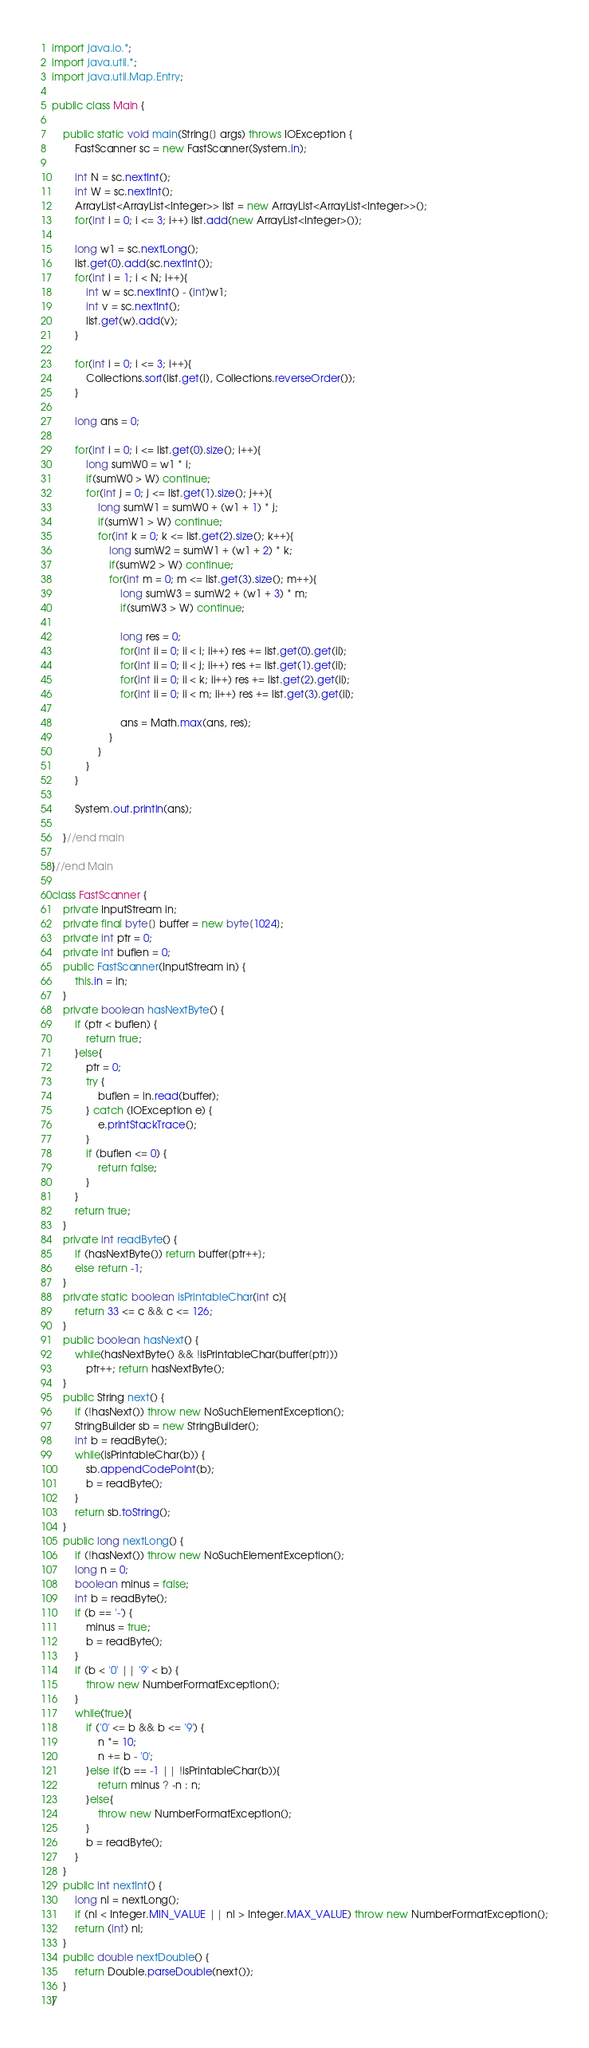<code> <loc_0><loc_0><loc_500><loc_500><_Java_>import java.io.*;
import java.util.*;
import java.util.Map.Entry;

public class Main {
		
	public static void main(String[] args) throws IOException {
		FastScanner sc = new FastScanner(System.in);
		
		int N = sc.nextInt();
		int W = sc.nextInt();
		ArrayList<ArrayList<Integer>> list = new ArrayList<ArrayList<Integer>>();
		for(int i = 0; i <= 3; i++) list.add(new ArrayList<Integer>());
		
		long w1 = sc.nextLong();
		list.get(0).add(sc.nextInt());
		for(int i = 1; i < N; i++){
			int w = sc.nextInt() - (int)w1;
			int v = sc.nextInt();
			list.get(w).add(v);
		}
		
		for(int i = 0; i <= 3; i++){
			Collections.sort(list.get(i), Collections.reverseOrder());
		}
		
		long ans = 0;
		
		for(int i = 0; i <= list.get(0).size(); i++){
			long sumW0 = w1 * i;
			if(sumW0 > W) continue;
			for(int j = 0; j <= list.get(1).size(); j++){
				long sumW1 = sumW0 + (w1 + 1) * j;
				if(sumW1 > W) continue;
				for(int k = 0; k <= list.get(2).size(); k++){
					long sumW2 = sumW1 + (w1 + 2) * k;
					if(sumW2 > W) continue;
					for(int m = 0; m <= list.get(3).size(); m++){
						long sumW3 = sumW2 + (w1 + 3) * m;
						if(sumW3 > W) continue;
						
						long res = 0;
						for(int ii = 0; ii < i; ii++) res += list.get(0).get(ii);
						for(int ii = 0; ii < j; ii++) res += list.get(1).get(ii);
						for(int ii = 0; ii < k; ii++) res += list.get(2).get(ii);
						for(int ii = 0; ii < m; ii++) res += list.get(3).get(ii);
						
						ans = Math.max(ans, res);
					}
				}
			}
		}
		
		System.out.println(ans);
		
	}//end main
	
}//end Main

class FastScanner {
    private InputStream in;
    private final byte[] buffer = new byte[1024];
    private int ptr = 0;
    private int buflen = 0;
    public FastScanner(InputStream in) {
		this.in = in;
	}
    private boolean hasNextByte() {
        if (ptr < buflen) {
            return true;
        }else{
            ptr = 0;
            try {
                buflen = in.read(buffer);
            } catch (IOException e) {
                e.printStackTrace();
            }
            if (buflen <= 0) {
                return false;
            }
        }
        return true;
    }
    private int readByte() {
    	if (hasNextByte()) return buffer[ptr++];
    	else return -1;
    }
    private static boolean isPrintableChar(int c){
    	return 33 <= c && c <= 126;
    }
    public boolean hasNext() {
    	while(hasNextByte() && !isPrintableChar(buffer[ptr]))
    		ptr++; return hasNextByte();
    }
    public String next() {
        if (!hasNext()) throw new NoSuchElementException();
        StringBuilder sb = new StringBuilder();
        int b = readByte();
        while(isPrintableChar(b)) {
            sb.appendCodePoint(b);
            b = readByte();
        }
        return sb.toString();
    }
    public long nextLong() {
        if (!hasNext()) throw new NoSuchElementException();
        long n = 0;
        boolean minus = false;
        int b = readByte();
        if (b == '-') {
            minus = true;
            b = readByte();
        }
        if (b < '0' || '9' < b) {
            throw new NumberFormatException();
        }
        while(true){
            if ('0' <= b && b <= '9') {
                n *= 10;
                n += b - '0';
            }else if(b == -1 || !isPrintableChar(b)){
                return minus ? -n : n;
            }else{
                throw new NumberFormatException();
            }
            b = readByte();
        }
    }
    public int nextInt() {
        long nl = nextLong();
        if (nl < Integer.MIN_VALUE || nl > Integer.MAX_VALUE) throw new NumberFormatException();
        return (int) nl;
    }
    public double nextDouble() {
    	return Double.parseDouble(next());
    }
}
</code> 